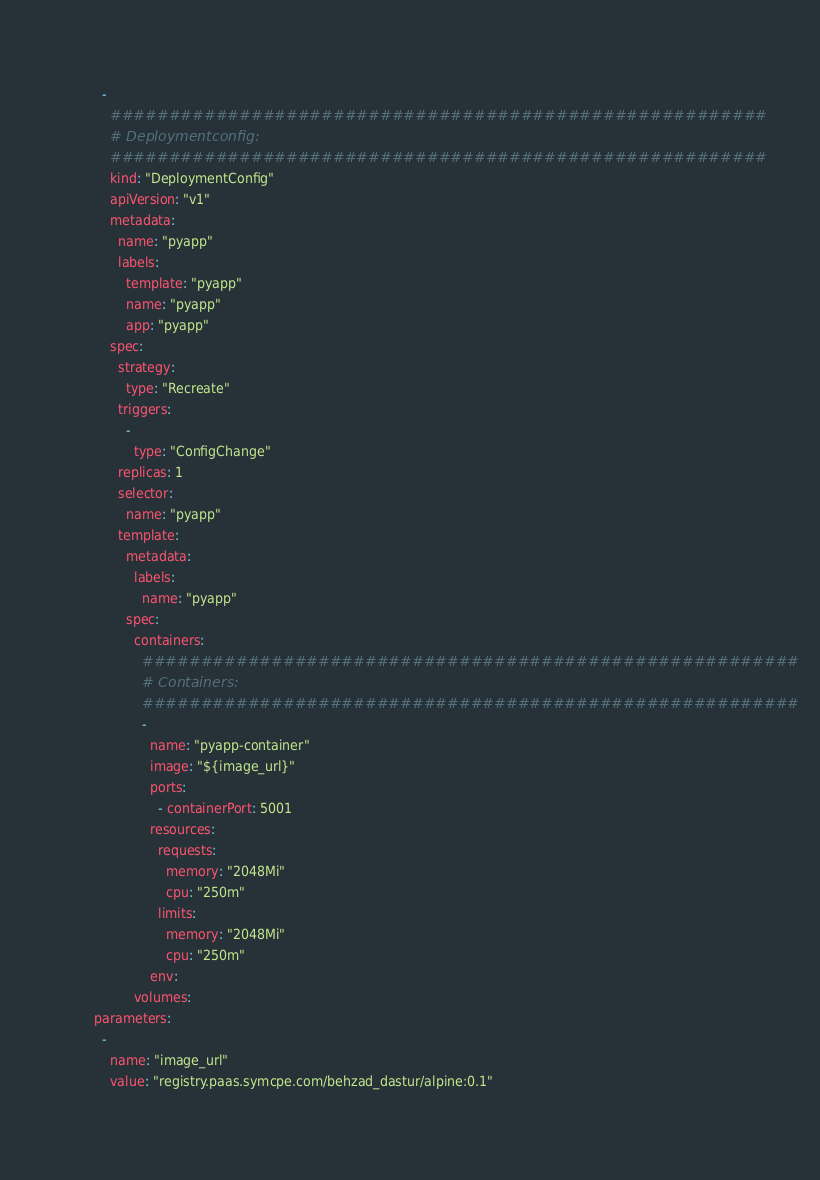<code> <loc_0><loc_0><loc_500><loc_500><_YAML_>    -
      ########################################################
      # Deploymentconfig:
      ########################################################
      kind: "DeploymentConfig"
      apiVersion: "v1"
      metadata:
        name: "pyapp"
        labels:
          template: "pyapp"
          name: "pyapp"
          app: "pyapp"
      spec:
        strategy:
          type: "Recreate"
        triggers:
          -
            type: "ConfigChange"
        replicas: 1
        selector:
          name: "pyapp"
        template:
          metadata:
            labels:
              name: "pyapp"
          spec:
            containers:
              ########################################################
              # Containers:
              ########################################################
              -
                name: "pyapp-container"
                image: "${image_url}"
                ports:
                  - containerPort: 5001
                resources:
                  requests:
                    memory: "2048Mi"
                    cpu: "250m"
                  limits:
                    memory: "2048Mi"
                    cpu: "250m"
                env:
            volumes:
  parameters:
    -
      name: "image_url"
      value: "registry.paas.symcpe.com/behzad_dastur/alpine:0.1"
</code> 